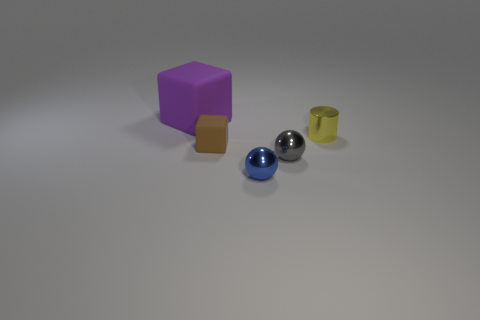How many objects are there, and can you describe their colors? There are five objects in the image. Starting from the left, we have a purple cube, a brown cube, a shiny blue sphere, a shiny grey sphere, and a yellow-green cylinder. Do the colors of the objects hold any significance? Without additional context, the significance of the colors cannot be accurately determined. They could be random or could have been chosen to create contrast and to differentiate between the objects in a composition study, for example. 